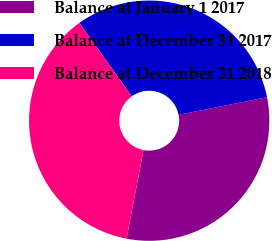Convert chart. <chart><loc_0><loc_0><loc_500><loc_500><pie_chart><fcel>Balance at January 1 2017<fcel>Balance at December 31 2017<fcel>Balance at December 31 2018<nl><fcel>31.15%<fcel>31.75%<fcel>37.1%<nl></chart> 